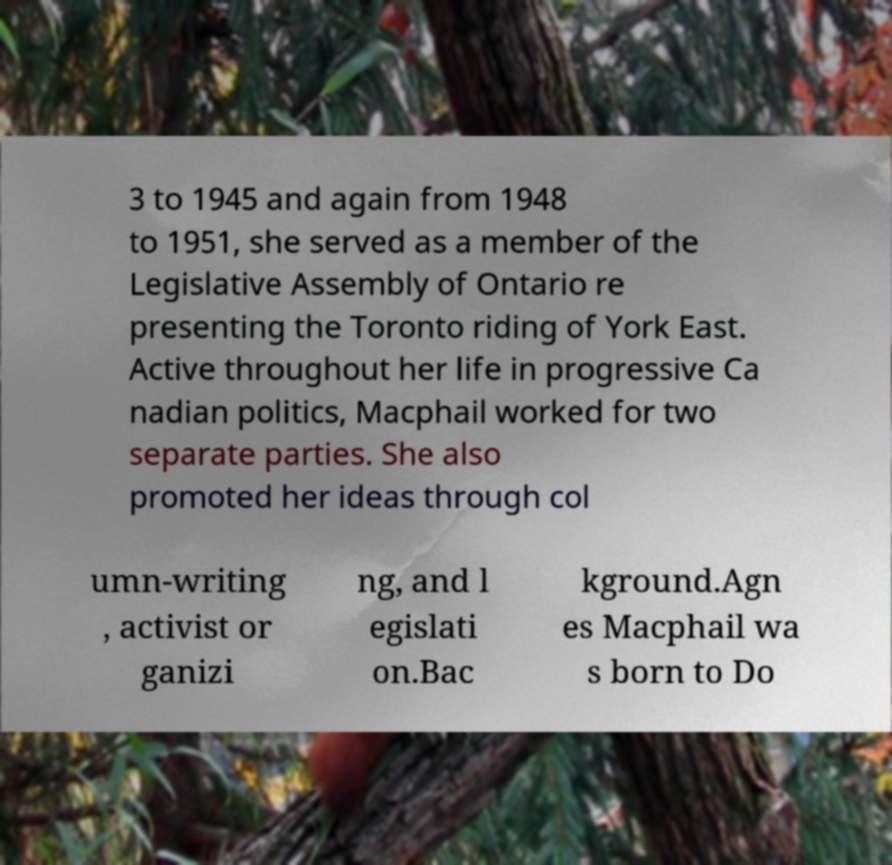Could you assist in decoding the text presented in this image and type it out clearly? 3 to 1945 and again from 1948 to 1951, she served as a member of the Legislative Assembly of Ontario re presenting the Toronto riding of York East. Active throughout her life in progressive Ca nadian politics, Macphail worked for two separate parties. She also promoted her ideas through col umn-writing , activist or ganizi ng, and l egislati on.Bac kground.Agn es Macphail wa s born to Do 